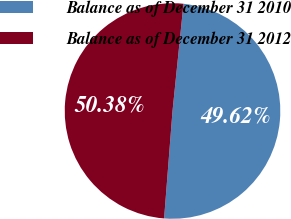Convert chart. <chart><loc_0><loc_0><loc_500><loc_500><pie_chart><fcel>Balance as of December 31 2010<fcel>Balance as of December 31 2012<nl><fcel>49.62%<fcel>50.38%<nl></chart> 